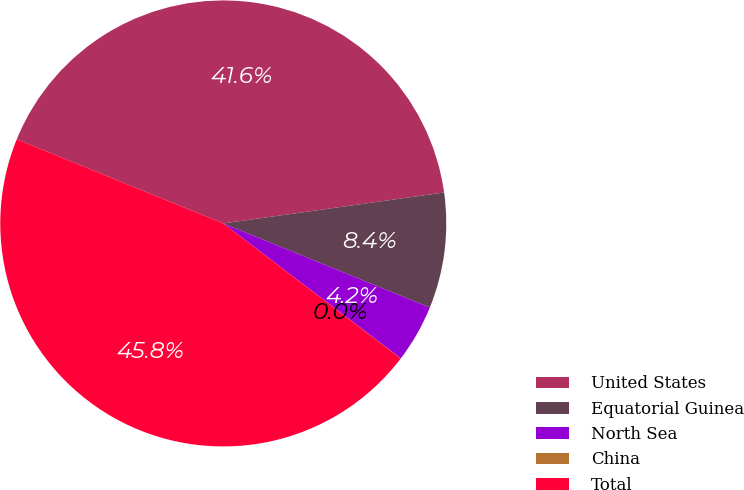Convert chart to OTSL. <chart><loc_0><loc_0><loc_500><loc_500><pie_chart><fcel>United States<fcel>Equatorial Guinea<fcel>North Sea<fcel>China<fcel>Total<nl><fcel>41.63%<fcel>8.37%<fcel>4.19%<fcel>0.01%<fcel>45.81%<nl></chart> 